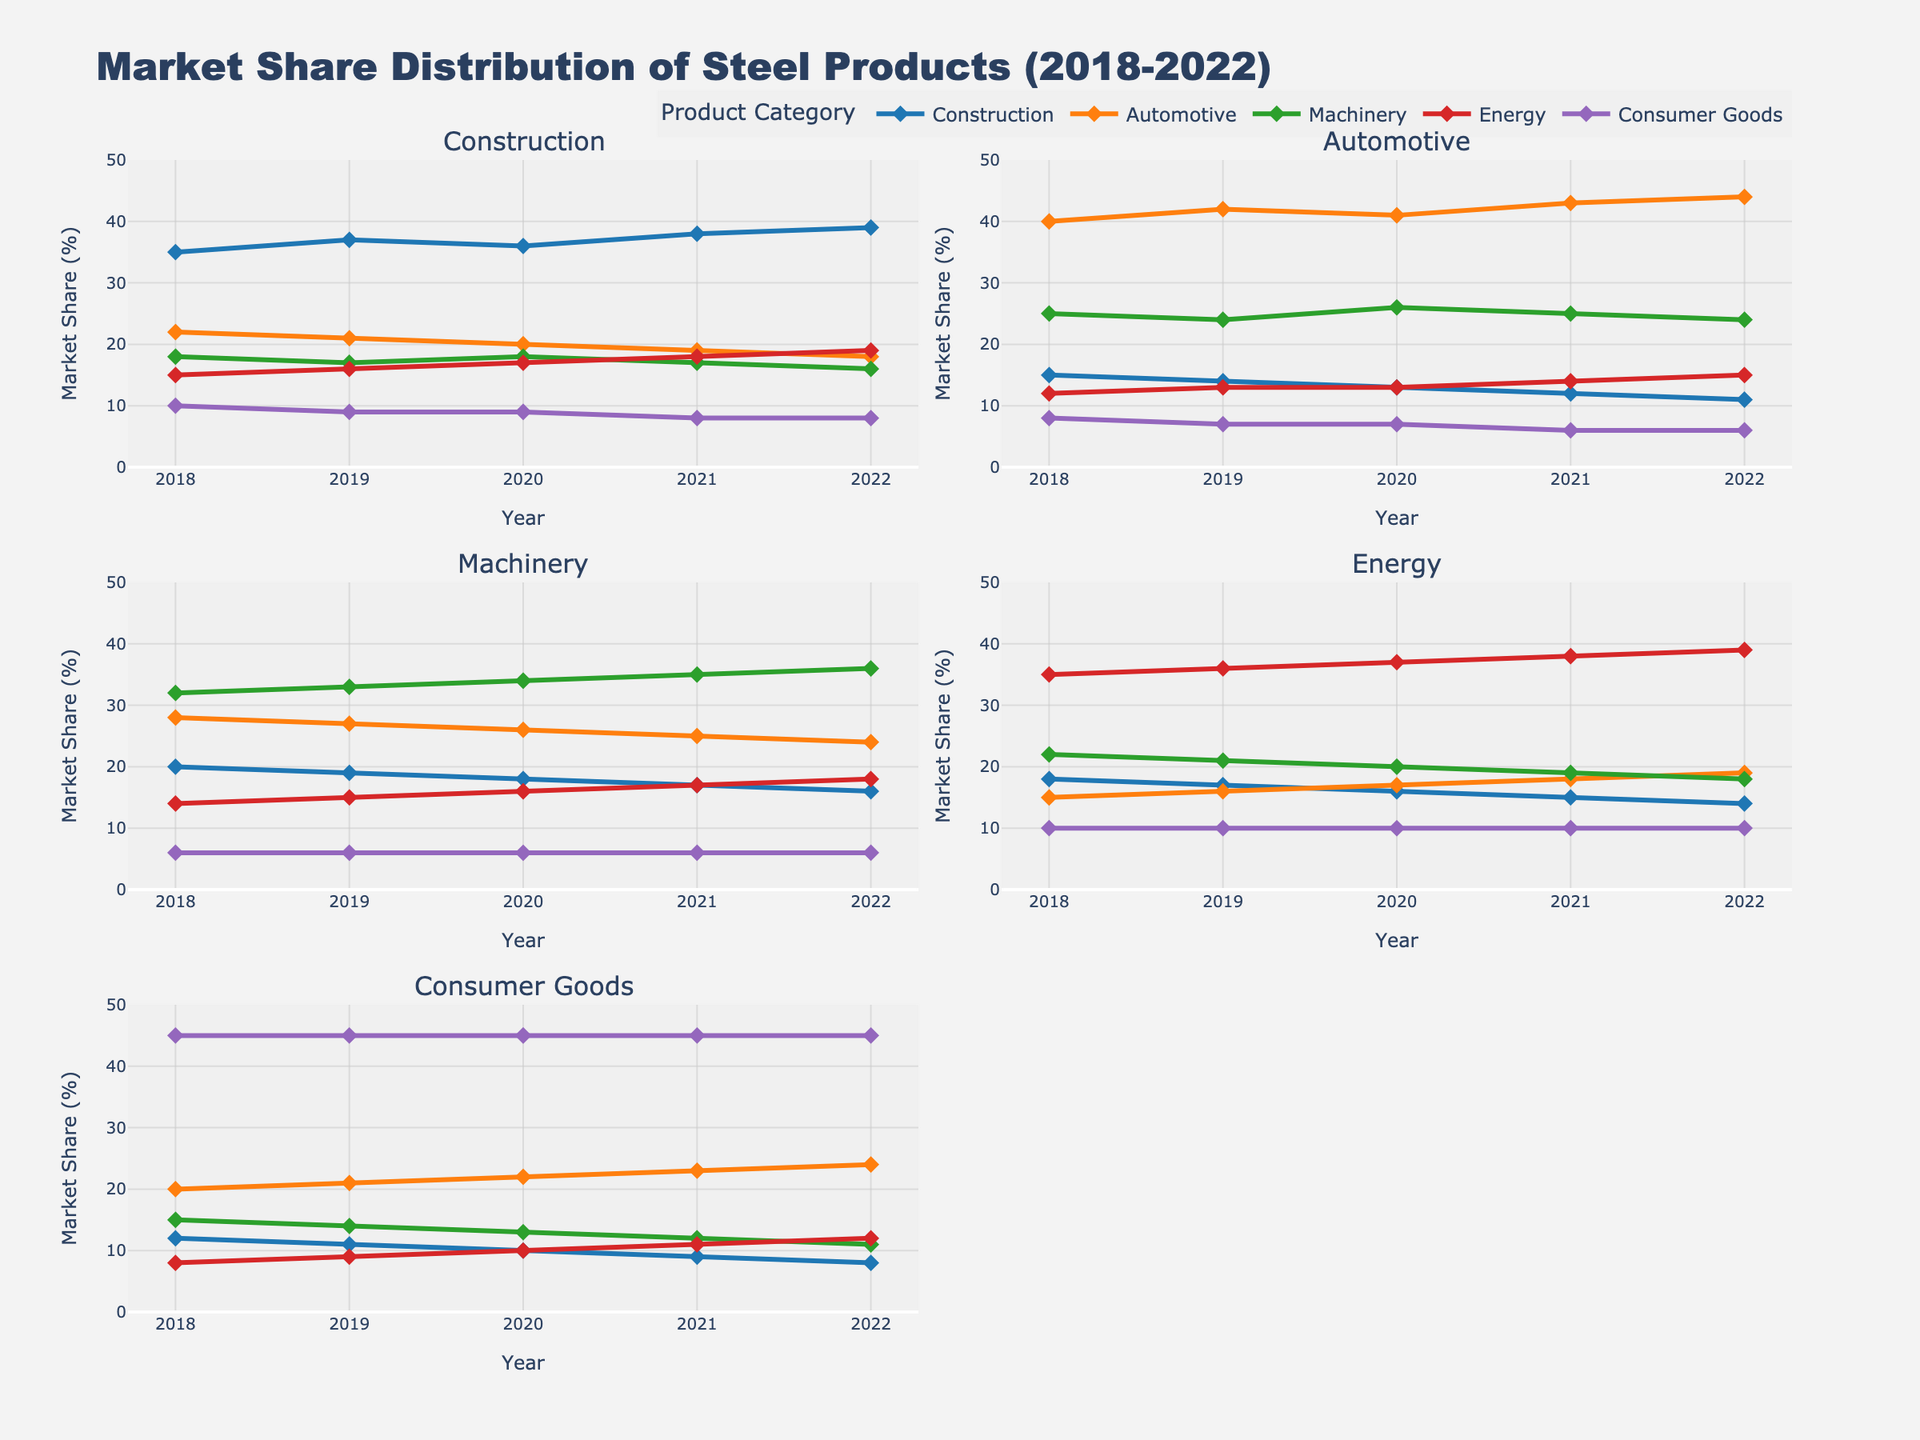What is the total sales amount for Miami-Dade county? The total sales amount for Miami-Dade county can be found in the first subplot (Total Sales by County), where Miami-Dade is listed at the top of the y-axis. The horizontal bar next to it represents the sales amount.
Answer: 4,170,000 Which county has the highest total sales? The county with the highest total sales is represented by the longest bar in the first subplot (Total Sales by County).
Answer: Miami-Dade What is the percentage of sales for the Electronics category? The sales distribution for the Electronics category is shown in the second subplot (Sales Distribution by Category) as a slice of the pie chart. To find the percentage, locate the value associated with Electronics in the legend.
Answer: 22.15% Which are the top 5 counties in terms of Electronics sales? The top 5 counties by Electronics sales are displayed in the third subplot (Top 5 Counties by Electronics Sales) using a vertical bar chart. The x-axis lists the top 5 counties.
Answer: Miami-Dade, Broward, Palm Beach, Orange, Hillsborough How does the sales of Appliances compare between Miami-Dade and Broward? In the fourth subplot (Sales Comparison Across Categories), find the markers for Appliances for both counties. Compare their y-values directly.
Answer: Miami-Dade: 980,000, Broward: 750,000 Which product category has the lowest sales in Hillsborough county? In the fourth subplot (Sales Comparison Across Categories), look for Hillsborough county on the x-axis and find the category with the smallest marker.
Answer: Outdoor What is the total sales amount for the category of Furniture? The total amount for Furniture is found in the second subplot (Sales Distribution by Category) as part of the pie chart. The value labeled as Furniture in the legend provides this information.
Answer: 4,930,000 Which county shows the lowest Clothing sales? In the first subplot (Total Sales by County), the horizontal bars show total sales, but for specific categories, look to the dots in the fourth subplot (Sales Comparison Across Categories). The dot for Clothing with the lowest y-value represents the lowest sales.
Answer: Brevard How do the Outdoor sales in Lee county compare to those in Pinellas county? Using the fourth subplot (Sales Comparison Across Categories), compare the y-values for Outdoor sales in Lee and Pinellas counties.
Answer: Lee: 290,000, Pinellas: 280,000 Is the Electronics sales volume higher than Clothing sales in Orange county? Look at the markers for Electronics and Clothing for Orange county in the fourth subplot (Sales Comparison Across Categories), then compare their positions on the y-axis.
Answer: Yes 